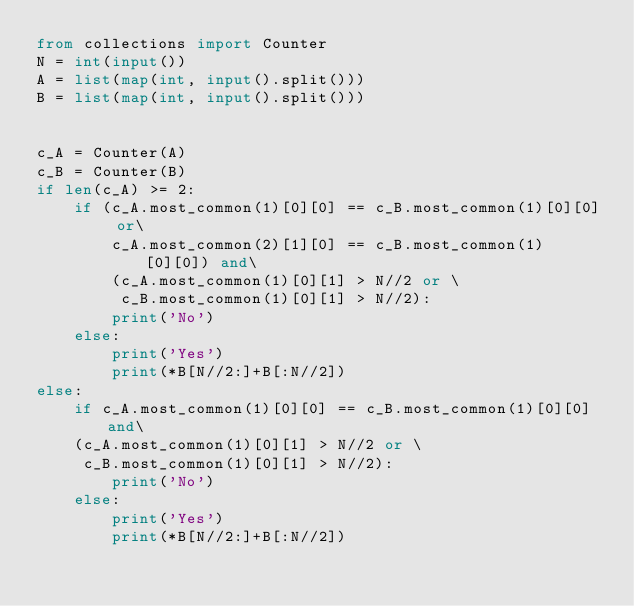<code> <loc_0><loc_0><loc_500><loc_500><_Python_>from collections import Counter
N = int(input())
A = list(map(int, input().split()))
B = list(map(int, input().split()))


c_A = Counter(A)
c_B = Counter(B)
if len(c_A) >= 2:
    if (c_A.most_common(1)[0][0] == c_B.most_common(1)[0][0] or\
        c_A.most_common(2)[1][0] == c_B.most_common(1)[0][0]) and\
        (c_A.most_common(1)[0][1] > N//2 or \
         c_B.most_common(1)[0][1] > N//2):
        print('No')
    else:
        print('Yes')
        print(*B[N//2:]+B[:N//2])
else:
    if c_A.most_common(1)[0][0] == c_B.most_common(1)[0][0] and\
    (c_A.most_common(1)[0][1] > N//2 or \
     c_B.most_common(1)[0][1] > N//2):
        print('No')
    else:
        print('Yes')
        print(*B[N//2:]+B[:N//2])</code> 